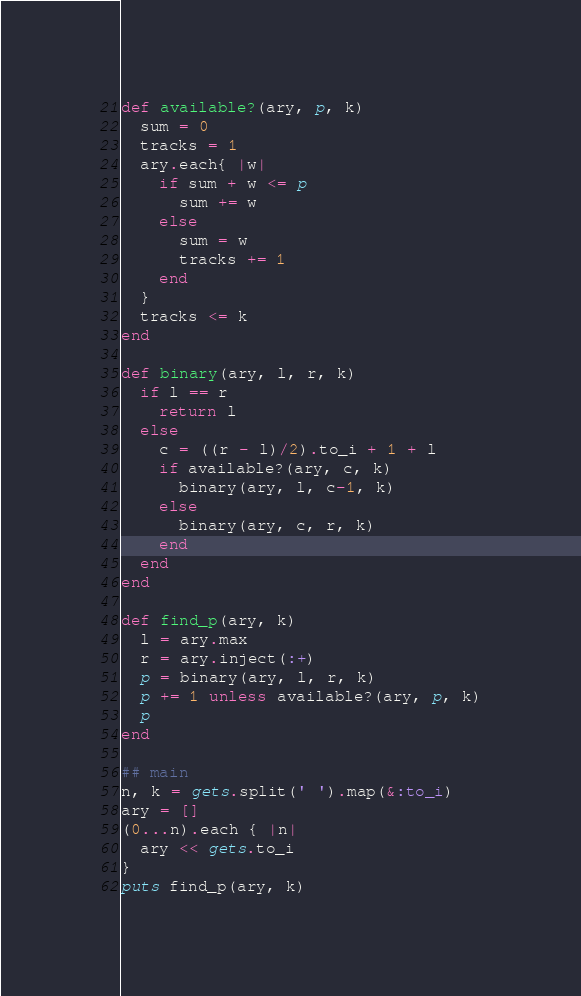<code> <loc_0><loc_0><loc_500><loc_500><_Ruby_>def available?(ary, p, k)
  sum = 0
  tracks = 1
  ary.each{ |w|
    if sum + w <= p
      sum += w
    else
      sum = w
      tracks += 1
    end
  }
  tracks <= k
end

def binary(ary, l, r, k)
  if l == r
    return l
  else
    c = ((r - l)/2).to_i + 1 + l
    if available?(ary, c, k)
      binary(ary, l, c-1, k)
    else
      binary(ary, c, r, k)
    end
  end
end

def find_p(ary, k)
  l = ary.max
  r = ary.inject(:+)
  p = binary(ary, l, r, k)
  p += 1 unless available?(ary, p, k)
  p
end

## main
n, k = gets.split(' ').map(&:to_i)
ary = []
(0...n).each { |n|
  ary << gets.to_i
}
puts find_p(ary, k)</code> 